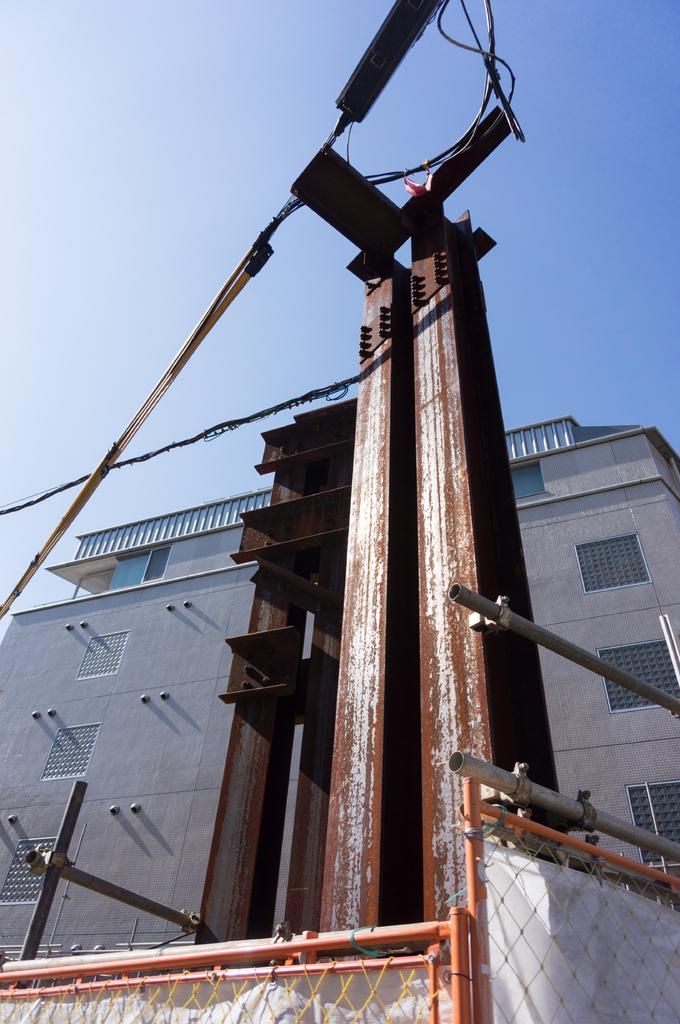What type of structure is visible in the image? There is a building in the image. What else can be seen connected to the building or nearby? There are cables connected to a pole in the image. What is visible in the background of the image? The sky is visible in the image. What might be used to prevent access or control movement in the image? There is a barrier at the bottom of the image. Are there any giants visible in the image? No, there are no giants present in the image. What type of toothbrush can be seen in the image? There is no toothbrush present in the image. 